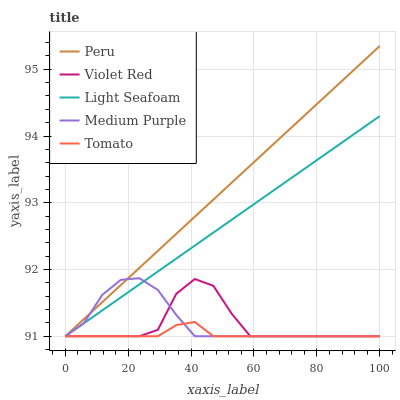Does Tomato have the minimum area under the curve?
Answer yes or no. Yes. Does Peru have the maximum area under the curve?
Answer yes or no. Yes. Does Violet Red have the minimum area under the curve?
Answer yes or no. No. Does Violet Red have the maximum area under the curve?
Answer yes or no. No. Is Peru the smoothest?
Answer yes or no. Yes. Is Violet Red the roughest?
Answer yes or no. Yes. Is Tomato the smoothest?
Answer yes or no. No. Is Tomato the roughest?
Answer yes or no. No. Does Peru have the highest value?
Answer yes or no. Yes. Does Violet Red have the highest value?
Answer yes or no. No. Does Violet Red intersect Light Seafoam?
Answer yes or no. Yes. Is Violet Red less than Light Seafoam?
Answer yes or no. No. Is Violet Red greater than Light Seafoam?
Answer yes or no. No. 